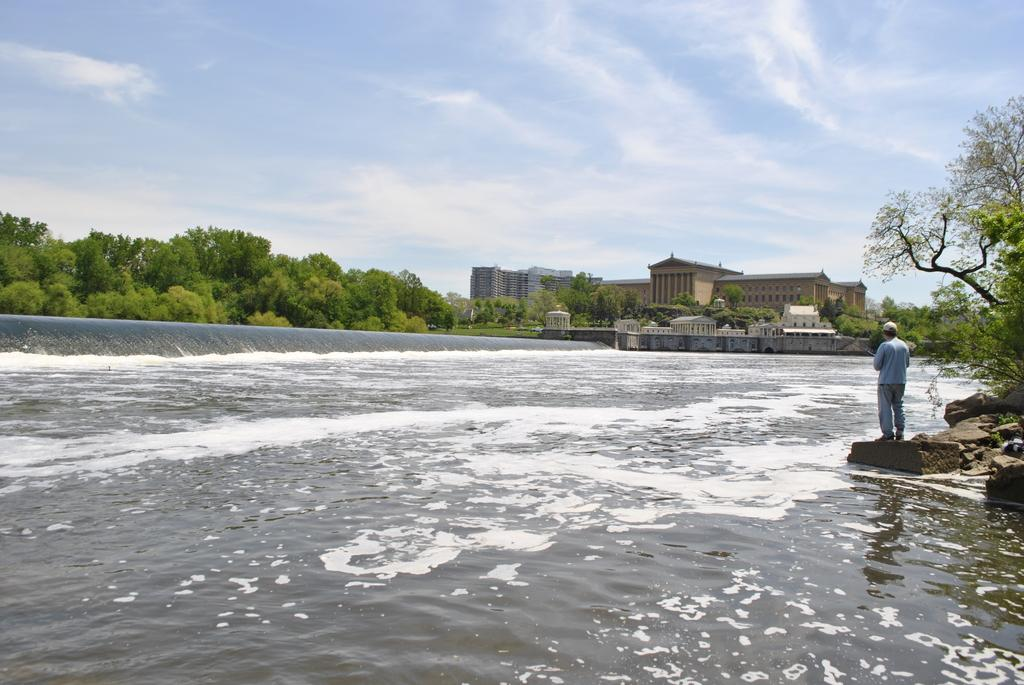What is the person in the image standing on? The person is standing on a stone in the image. What can be seen in the background of the image? There is water, trees, buildings, and the sky visible in the image. What is the condition of the sky in the image? The sky is visible in the image, and clouds are present. How many bikes are being ridden by lizards in the image? There are no bikes or lizards present in the image. What type of straw is being used by the person in the image? There is no straw visible in the image. 